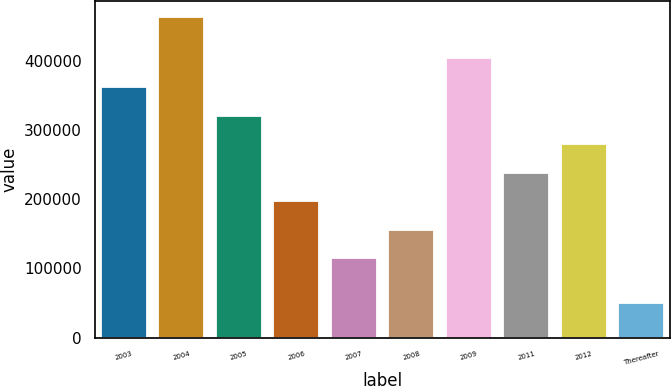<chart> <loc_0><loc_0><loc_500><loc_500><bar_chart><fcel>2003<fcel>2004<fcel>2005<fcel>2006<fcel>2007<fcel>2008<fcel>2009<fcel>2011<fcel>2012<fcel>Thereafter<nl><fcel>361906<fcel>462151<fcel>320690<fcel>197045<fcel>114615<fcel>155830<fcel>403121<fcel>238260<fcel>279475<fcel>50000<nl></chart> 